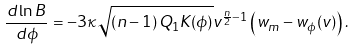Convert formula to latex. <formula><loc_0><loc_0><loc_500><loc_500>\frac { d \ln B } { d \phi } = - 3 \kappa \sqrt { \left ( n - 1 \right ) Q _ { 1 } K ( \phi ) } v ^ { \frac { n } { 2 } - 1 } \left ( w _ { m } - w _ { \phi } ( v ) \right ) .</formula> 